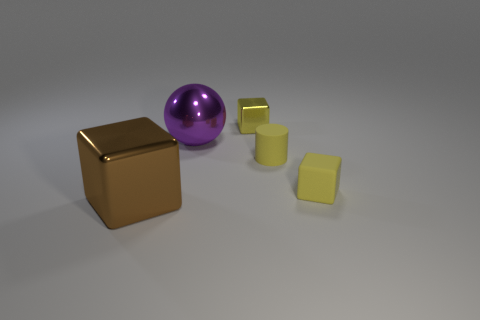Do the big purple object and the yellow cylinder have the same material?
Provide a succinct answer. No. The matte block that is the same size as the cylinder is what color?
Your answer should be very brief. Yellow. The thing that is to the left of the small metal cube and right of the big brown cube is what color?
Give a very brief answer. Purple. There is a matte cube that is the same color as the tiny rubber cylinder; what is its size?
Your answer should be compact. Small. There is a metallic object that is the same color as the cylinder; what is its shape?
Give a very brief answer. Cube. There is a metallic block that is behind the tiny cube to the right of the tiny yellow metal block that is to the right of the big purple sphere; what is its size?
Offer a terse response. Small. What material is the tiny cylinder?
Give a very brief answer. Rubber. Is the big purple ball made of the same material as the yellow cylinder that is to the right of the large brown metal cube?
Provide a short and direct response. No. Is there anything else that has the same color as the small matte cylinder?
Offer a very short reply. Yes. Is there a small metallic cube in front of the cube behind the small yellow block right of the yellow matte cylinder?
Your answer should be very brief. No. 